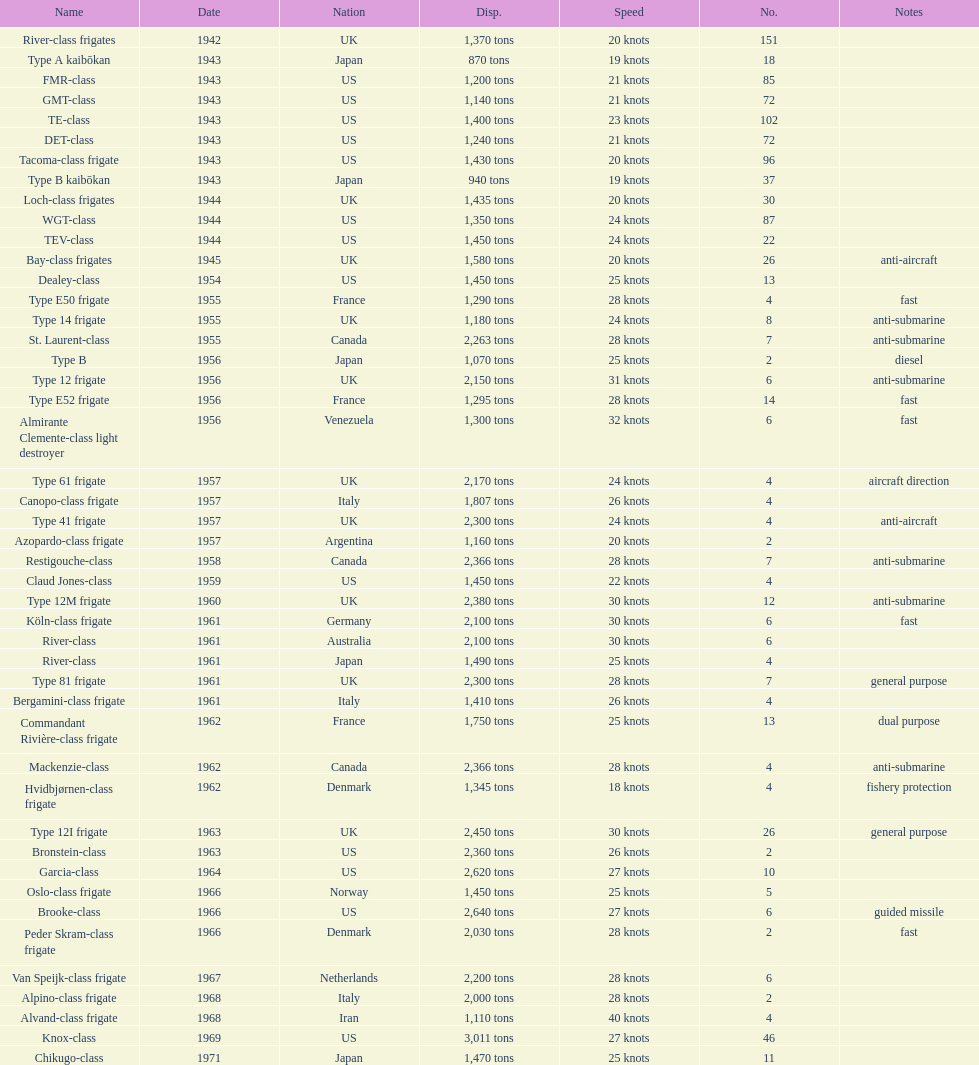How many consecutive escorts were in 1943? 7. 